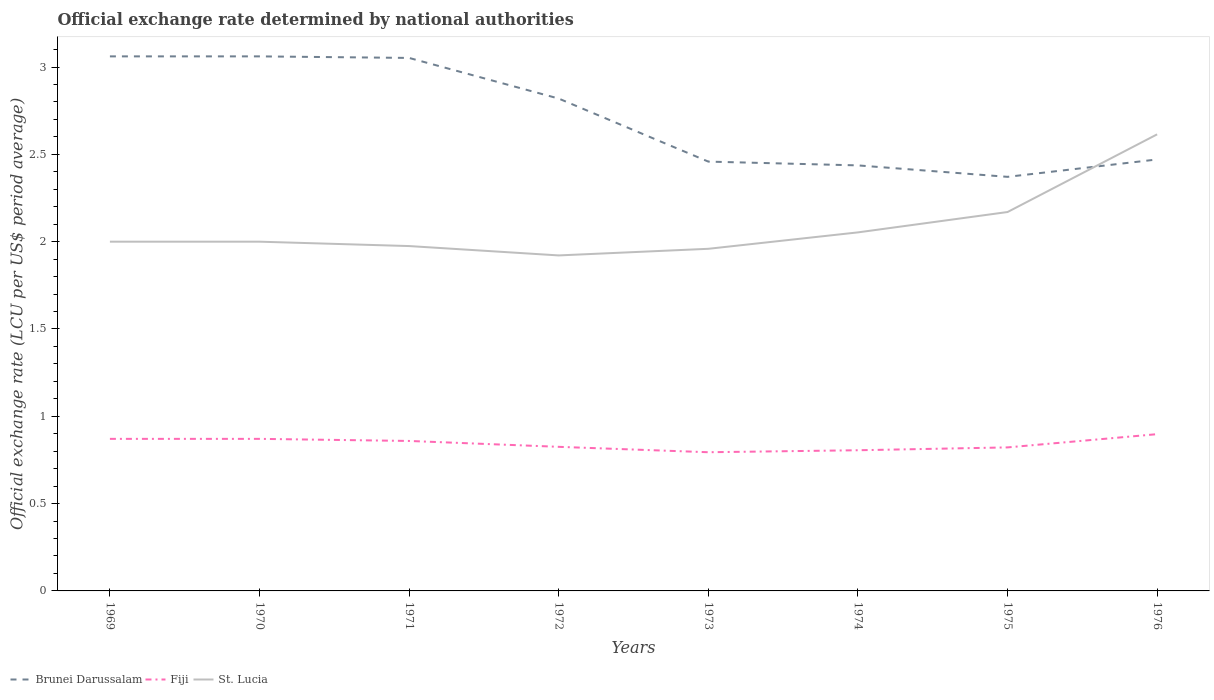How many different coloured lines are there?
Offer a terse response. 3. Is the number of lines equal to the number of legend labels?
Offer a terse response. Yes. Across all years, what is the maximum official exchange rate in St. Lucia?
Your response must be concise. 1.92. In which year was the official exchange rate in St. Lucia maximum?
Keep it short and to the point. 1972. What is the total official exchange rate in St. Lucia in the graph?
Ensure brevity in your answer.  -0.08. What is the difference between the highest and the second highest official exchange rate in St. Lucia?
Make the answer very short. 0.69. Is the official exchange rate in Brunei Darussalam strictly greater than the official exchange rate in St. Lucia over the years?
Make the answer very short. No. How are the legend labels stacked?
Keep it short and to the point. Horizontal. What is the title of the graph?
Keep it short and to the point. Official exchange rate determined by national authorities. Does "Slovenia" appear as one of the legend labels in the graph?
Your answer should be compact. No. What is the label or title of the Y-axis?
Give a very brief answer. Official exchange rate (LCU per US$ period average). What is the Official exchange rate (LCU per US$ period average) in Brunei Darussalam in 1969?
Your answer should be very brief. 3.06. What is the Official exchange rate (LCU per US$ period average) of Fiji in 1969?
Ensure brevity in your answer.  0.87. What is the Official exchange rate (LCU per US$ period average) of St. Lucia in 1969?
Offer a very short reply. 2. What is the Official exchange rate (LCU per US$ period average) of Brunei Darussalam in 1970?
Provide a succinct answer. 3.06. What is the Official exchange rate (LCU per US$ period average) of Fiji in 1970?
Ensure brevity in your answer.  0.87. What is the Official exchange rate (LCU per US$ period average) in St. Lucia in 1970?
Give a very brief answer. 2. What is the Official exchange rate (LCU per US$ period average) in Brunei Darussalam in 1971?
Your answer should be very brief. 3.05. What is the Official exchange rate (LCU per US$ period average) in Fiji in 1971?
Offer a terse response. 0.86. What is the Official exchange rate (LCU per US$ period average) of St. Lucia in 1971?
Offer a very short reply. 1.97. What is the Official exchange rate (LCU per US$ period average) in Brunei Darussalam in 1972?
Give a very brief answer. 2.82. What is the Official exchange rate (LCU per US$ period average) of Fiji in 1972?
Keep it short and to the point. 0.83. What is the Official exchange rate (LCU per US$ period average) in St. Lucia in 1972?
Provide a succinct answer. 1.92. What is the Official exchange rate (LCU per US$ period average) of Brunei Darussalam in 1973?
Your answer should be compact. 2.46. What is the Official exchange rate (LCU per US$ period average) of Fiji in 1973?
Give a very brief answer. 0.79. What is the Official exchange rate (LCU per US$ period average) of St. Lucia in 1973?
Make the answer very short. 1.96. What is the Official exchange rate (LCU per US$ period average) of Brunei Darussalam in 1974?
Give a very brief answer. 2.44. What is the Official exchange rate (LCU per US$ period average) in Fiji in 1974?
Ensure brevity in your answer.  0.81. What is the Official exchange rate (LCU per US$ period average) in St. Lucia in 1974?
Offer a very short reply. 2.05. What is the Official exchange rate (LCU per US$ period average) in Brunei Darussalam in 1975?
Keep it short and to the point. 2.37. What is the Official exchange rate (LCU per US$ period average) of Fiji in 1975?
Give a very brief answer. 0.82. What is the Official exchange rate (LCU per US$ period average) in St. Lucia in 1975?
Offer a very short reply. 2.17. What is the Official exchange rate (LCU per US$ period average) in Brunei Darussalam in 1976?
Ensure brevity in your answer.  2.47. What is the Official exchange rate (LCU per US$ period average) of Fiji in 1976?
Ensure brevity in your answer.  0.9. What is the Official exchange rate (LCU per US$ period average) in St. Lucia in 1976?
Ensure brevity in your answer.  2.61. Across all years, what is the maximum Official exchange rate (LCU per US$ period average) of Brunei Darussalam?
Give a very brief answer. 3.06. Across all years, what is the maximum Official exchange rate (LCU per US$ period average) of Fiji?
Provide a short and direct response. 0.9. Across all years, what is the maximum Official exchange rate (LCU per US$ period average) of St. Lucia?
Your answer should be very brief. 2.61. Across all years, what is the minimum Official exchange rate (LCU per US$ period average) of Brunei Darussalam?
Provide a short and direct response. 2.37. Across all years, what is the minimum Official exchange rate (LCU per US$ period average) in Fiji?
Your answer should be compact. 0.79. Across all years, what is the minimum Official exchange rate (LCU per US$ period average) in St. Lucia?
Offer a very short reply. 1.92. What is the total Official exchange rate (LCU per US$ period average) of Brunei Darussalam in the graph?
Make the answer very short. 21.73. What is the total Official exchange rate (LCU per US$ period average) in Fiji in the graph?
Ensure brevity in your answer.  6.75. What is the total Official exchange rate (LCU per US$ period average) of St. Lucia in the graph?
Make the answer very short. 16.69. What is the difference between the Official exchange rate (LCU per US$ period average) in Brunei Darussalam in 1969 and that in 1970?
Your answer should be very brief. 0. What is the difference between the Official exchange rate (LCU per US$ period average) in Brunei Darussalam in 1969 and that in 1971?
Provide a succinct answer. 0.01. What is the difference between the Official exchange rate (LCU per US$ period average) in Fiji in 1969 and that in 1971?
Your response must be concise. 0.01. What is the difference between the Official exchange rate (LCU per US$ period average) in St. Lucia in 1969 and that in 1971?
Ensure brevity in your answer.  0.03. What is the difference between the Official exchange rate (LCU per US$ period average) in Brunei Darussalam in 1969 and that in 1972?
Offer a very short reply. 0.24. What is the difference between the Official exchange rate (LCU per US$ period average) of Fiji in 1969 and that in 1972?
Your answer should be compact. 0.05. What is the difference between the Official exchange rate (LCU per US$ period average) of St. Lucia in 1969 and that in 1972?
Your answer should be compact. 0.08. What is the difference between the Official exchange rate (LCU per US$ period average) of Brunei Darussalam in 1969 and that in 1973?
Make the answer very short. 0.6. What is the difference between the Official exchange rate (LCU per US$ period average) in Fiji in 1969 and that in 1973?
Offer a very short reply. 0.08. What is the difference between the Official exchange rate (LCU per US$ period average) of St. Lucia in 1969 and that in 1973?
Give a very brief answer. 0.04. What is the difference between the Official exchange rate (LCU per US$ period average) of Brunei Darussalam in 1969 and that in 1974?
Your answer should be very brief. 0.62. What is the difference between the Official exchange rate (LCU per US$ period average) in Fiji in 1969 and that in 1974?
Keep it short and to the point. 0.07. What is the difference between the Official exchange rate (LCU per US$ period average) of St. Lucia in 1969 and that in 1974?
Your response must be concise. -0.05. What is the difference between the Official exchange rate (LCU per US$ period average) in Brunei Darussalam in 1969 and that in 1975?
Offer a terse response. 0.69. What is the difference between the Official exchange rate (LCU per US$ period average) of Fiji in 1969 and that in 1975?
Your answer should be compact. 0.05. What is the difference between the Official exchange rate (LCU per US$ period average) in St. Lucia in 1969 and that in 1975?
Give a very brief answer. -0.17. What is the difference between the Official exchange rate (LCU per US$ period average) of Brunei Darussalam in 1969 and that in 1976?
Offer a very short reply. 0.59. What is the difference between the Official exchange rate (LCU per US$ period average) of Fiji in 1969 and that in 1976?
Make the answer very short. -0.03. What is the difference between the Official exchange rate (LCU per US$ period average) in St. Lucia in 1969 and that in 1976?
Make the answer very short. -0.61. What is the difference between the Official exchange rate (LCU per US$ period average) in Brunei Darussalam in 1970 and that in 1971?
Provide a succinct answer. 0.01. What is the difference between the Official exchange rate (LCU per US$ period average) in Fiji in 1970 and that in 1971?
Give a very brief answer. 0.01. What is the difference between the Official exchange rate (LCU per US$ period average) of St. Lucia in 1970 and that in 1971?
Your response must be concise. 0.03. What is the difference between the Official exchange rate (LCU per US$ period average) of Brunei Darussalam in 1970 and that in 1972?
Provide a short and direct response. 0.24. What is the difference between the Official exchange rate (LCU per US$ period average) in Fiji in 1970 and that in 1972?
Make the answer very short. 0.05. What is the difference between the Official exchange rate (LCU per US$ period average) in St. Lucia in 1970 and that in 1972?
Provide a succinct answer. 0.08. What is the difference between the Official exchange rate (LCU per US$ period average) of Brunei Darussalam in 1970 and that in 1973?
Your response must be concise. 0.6. What is the difference between the Official exchange rate (LCU per US$ period average) in Fiji in 1970 and that in 1973?
Ensure brevity in your answer.  0.08. What is the difference between the Official exchange rate (LCU per US$ period average) in St. Lucia in 1970 and that in 1973?
Ensure brevity in your answer.  0.04. What is the difference between the Official exchange rate (LCU per US$ period average) of Brunei Darussalam in 1970 and that in 1974?
Keep it short and to the point. 0.62. What is the difference between the Official exchange rate (LCU per US$ period average) in Fiji in 1970 and that in 1974?
Offer a terse response. 0.07. What is the difference between the Official exchange rate (LCU per US$ period average) of St. Lucia in 1970 and that in 1974?
Make the answer very short. -0.05. What is the difference between the Official exchange rate (LCU per US$ period average) of Brunei Darussalam in 1970 and that in 1975?
Give a very brief answer. 0.69. What is the difference between the Official exchange rate (LCU per US$ period average) in Fiji in 1970 and that in 1975?
Your response must be concise. 0.05. What is the difference between the Official exchange rate (LCU per US$ period average) of St. Lucia in 1970 and that in 1975?
Your answer should be very brief. -0.17. What is the difference between the Official exchange rate (LCU per US$ period average) in Brunei Darussalam in 1970 and that in 1976?
Keep it short and to the point. 0.59. What is the difference between the Official exchange rate (LCU per US$ period average) of Fiji in 1970 and that in 1976?
Keep it short and to the point. -0.03. What is the difference between the Official exchange rate (LCU per US$ period average) of St. Lucia in 1970 and that in 1976?
Offer a terse response. -0.61. What is the difference between the Official exchange rate (LCU per US$ period average) in Brunei Darussalam in 1971 and that in 1972?
Your answer should be very brief. 0.23. What is the difference between the Official exchange rate (LCU per US$ period average) in Fiji in 1971 and that in 1972?
Offer a terse response. 0.03. What is the difference between the Official exchange rate (LCU per US$ period average) in St. Lucia in 1971 and that in 1972?
Keep it short and to the point. 0.05. What is the difference between the Official exchange rate (LCU per US$ period average) in Brunei Darussalam in 1971 and that in 1973?
Offer a terse response. 0.59. What is the difference between the Official exchange rate (LCU per US$ period average) in Fiji in 1971 and that in 1973?
Offer a terse response. 0.06. What is the difference between the Official exchange rate (LCU per US$ period average) of St. Lucia in 1971 and that in 1973?
Your answer should be compact. 0.02. What is the difference between the Official exchange rate (LCU per US$ period average) in Brunei Darussalam in 1971 and that in 1974?
Make the answer very short. 0.62. What is the difference between the Official exchange rate (LCU per US$ period average) of Fiji in 1971 and that in 1974?
Give a very brief answer. 0.05. What is the difference between the Official exchange rate (LCU per US$ period average) of St. Lucia in 1971 and that in 1974?
Your response must be concise. -0.08. What is the difference between the Official exchange rate (LCU per US$ period average) in Brunei Darussalam in 1971 and that in 1975?
Make the answer very short. 0.68. What is the difference between the Official exchange rate (LCU per US$ period average) of Fiji in 1971 and that in 1975?
Your answer should be compact. 0.04. What is the difference between the Official exchange rate (LCU per US$ period average) in St. Lucia in 1971 and that in 1975?
Ensure brevity in your answer.  -0.19. What is the difference between the Official exchange rate (LCU per US$ period average) in Brunei Darussalam in 1971 and that in 1976?
Provide a succinct answer. 0.58. What is the difference between the Official exchange rate (LCU per US$ period average) in Fiji in 1971 and that in 1976?
Your answer should be compact. -0.04. What is the difference between the Official exchange rate (LCU per US$ period average) in St. Lucia in 1971 and that in 1976?
Ensure brevity in your answer.  -0.64. What is the difference between the Official exchange rate (LCU per US$ period average) in Brunei Darussalam in 1972 and that in 1973?
Provide a succinct answer. 0.36. What is the difference between the Official exchange rate (LCU per US$ period average) of Fiji in 1972 and that in 1973?
Provide a succinct answer. 0.03. What is the difference between the Official exchange rate (LCU per US$ period average) in St. Lucia in 1972 and that in 1973?
Provide a succinct answer. -0.04. What is the difference between the Official exchange rate (LCU per US$ period average) in Brunei Darussalam in 1972 and that in 1974?
Provide a short and direct response. 0.38. What is the difference between the Official exchange rate (LCU per US$ period average) of Fiji in 1972 and that in 1974?
Offer a terse response. 0.02. What is the difference between the Official exchange rate (LCU per US$ period average) in St. Lucia in 1972 and that in 1974?
Give a very brief answer. -0.13. What is the difference between the Official exchange rate (LCU per US$ period average) in Brunei Darussalam in 1972 and that in 1975?
Offer a very short reply. 0.45. What is the difference between the Official exchange rate (LCU per US$ period average) of Fiji in 1972 and that in 1975?
Make the answer very short. 0. What is the difference between the Official exchange rate (LCU per US$ period average) in St. Lucia in 1972 and that in 1975?
Offer a terse response. -0.25. What is the difference between the Official exchange rate (LCU per US$ period average) in Brunei Darussalam in 1972 and that in 1976?
Your answer should be very brief. 0.35. What is the difference between the Official exchange rate (LCU per US$ period average) of Fiji in 1972 and that in 1976?
Your answer should be compact. -0.07. What is the difference between the Official exchange rate (LCU per US$ period average) of St. Lucia in 1972 and that in 1976?
Your response must be concise. -0.69. What is the difference between the Official exchange rate (LCU per US$ period average) in Brunei Darussalam in 1973 and that in 1974?
Keep it short and to the point. 0.02. What is the difference between the Official exchange rate (LCU per US$ period average) in Fiji in 1973 and that in 1974?
Keep it short and to the point. -0.01. What is the difference between the Official exchange rate (LCU per US$ period average) in St. Lucia in 1973 and that in 1974?
Ensure brevity in your answer.  -0.09. What is the difference between the Official exchange rate (LCU per US$ period average) of Brunei Darussalam in 1973 and that in 1975?
Your answer should be compact. 0.09. What is the difference between the Official exchange rate (LCU per US$ period average) of Fiji in 1973 and that in 1975?
Ensure brevity in your answer.  -0.03. What is the difference between the Official exchange rate (LCU per US$ period average) in St. Lucia in 1973 and that in 1975?
Your answer should be very brief. -0.21. What is the difference between the Official exchange rate (LCU per US$ period average) in Brunei Darussalam in 1973 and that in 1976?
Give a very brief answer. -0.01. What is the difference between the Official exchange rate (LCU per US$ period average) of Fiji in 1973 and that in 1976?
Your answer should be compact. -0.1. What is the difference between the Official exchange rate (LCU per US$ period average) of St. Lucia in 1973 and that in 1976?
Ensure brevity in your answer.  -0.66. What is the difference between the Official exchange rate (LCU per US$ period average) of Brunei Darussalam in 1974 and that in 1975?
Give a very brief answer. 0.07. What is the difference between the Official exchange rate (LCU per US$ period average) of Fiji in 1974 and that in 1975?
Provide a short and direct response. -0.02. What is the difference between the Official exchange rate (LCU per US$ period average) of St. Lucia in 1974 and that in 1975?
Your answer should be compact. -0.12. What is the difference between the Official exchange rate (LCU per US$ period average) in Brunei Darussalam in 1974 and that in 1976?
Your answer should be very brief. -0.03. What is the difference between the Official exchange rate (LCU per US$ period average) of Fiji in 1974 and that in 1976?
Your response must be concise. -0.09. What is the difference between the Official exchange rate (LCU per US$ period average) of St. Lucia in 1974 and that in 1976?
Provide a short and direct response. -0.56. What is the difference between the Official exchange rate (LCU per US$ period average) of Brunei Darussalam in 1975 and that in 1976?
Your answer should be very brief. -0.1. What is the difference between the Official exchange rate (LCU per US$ period average) of Fiji in 1975 and that in 1976?
Offer a very short reply. -0.08. What is the difference between the Official exchange rate (LCU per US$ period average) of St. Lucia in 1975 and that in 1976?
Give a very brief answer. -0.44. What is the difference between the Official exchange rate (LCU per US$ period average) of Brunei Darussalam in 1969 and the Official exchange rate (LCU per US$ period average) of Fiji in 1970?
Your response must be concise. 2.19. What is the difference between the Official exchange rate (LCU per US$ period average) of Brunei Darussalam in 1969 and the Official exchange rate (LCU per US$ period average) of St. Lucia in 1970?
Ensure brevity in your answer.  1.06. What is the difference between the Official exchange rate (LCU per US$ period average) in Fiji in 1969 and the Official exchange rate (LCU per US$ period average) in St. Lucia in 1970?
Your answer should be very brief. -1.13. What is the difference between the Official exchange rate (LCU per US$ period average) of Brunei Darussalam in 1969 and the Official exchange rate (LCU per US$ period average) of Fiji in 1971?
Your answer should be compact. 2.2. What is the difference between the Official exchange rate (LCU per US$ period average) in Brunei Darussalam in 1969 and the Official exchange rate (LCU per US$ period average) in St. Lucia in 1971?
Your response must be concise. 1.09. What is the difference between the Official exchange rate (LCU per US$ period average) of Fiji in 1969 and the Official exchange rate (LCU per US$ period average) of St. Lucia in 1971?
Your answer should be very brief. -1.1. What is the difference between the Official exchange rate (LCU per US$ period average) of Brunei Darussalam in 1969 and the Official exchange rate (LCU per US$ period average) of Fiji in 1972?
Provide a succinct answer. 2.24. What is the difference between the Official exchange rate (LCU per US$ period average) in Brunei Darussalam in 1969 and the Official exchange rate (LCU per US$ period average) in St. Lucia in 1972?
Offer a terse response. 1.14. What is the difference between the Official exchange rate (LCU per US$ period average) of Fiji in 1969 and the Official exchange rate (LCU per US$ period average) of St. Lucia in 1972?
Your response must be concise. -1.05. What is the difference between the Official exchange rate (LCU per US$ period average) in Brunei Darussalam in 1969 and the Official exchange rate (LCU per US$ period average) in Fiji in 1973?
Provide a succinct answer. 2.27. What is the difference between the Official exchange rate (LCU per US$ period average) of Brunei Darussalam in 1969 and the Official exchange rate (LCU per US$ period average) of St. Lucia in 1973?
Offer a terse response. 1.1. What is the difference between the Official exchange rate (LCU per US$ period average) of Fiji in 1969 and the Official exchange rate (LCU per US$ period average) of St. Lucia in 1973?
Keep it short and to the point. -1.09. What is the difference between the Official exchange rate (LCU per US$ period average) of Brunei Darussalam in 1969 and the Official exchange rate (LCU per US$ period average) of Fiji in 1974?
Ensure brevity in your answer.  2.26. What is the difference between the Official exchange rate (LCU per US$ period average) in Fiji in 1969 and the Official exchange rate (LCU per US$ period average) in St. Lucia in 1974?
Provide a short and direct response. -1.18. What is the difference between the Official exchange rate (LCU per US$ period average) of Brunei Darussalam in 1969 and the Official exchange rate (LCU per US$ period average) of Fiji in 1975?
Give a very brief answer. 2.24. What is the difference between the Official exchange rate (LCU per US$ period average) of Brunei Darussalam in 1969 and the Official exchange rate (LCU per US$ period average) of St. Lucia in 1975?
Keep it short and to the point. 0.89. What is the difference between the Official exchange rate (LCU per US$ period average) of Fiji in 1969 and the Official exchange rate (LCU per US$ period average) of St. Lucia in 1975?
Your answer should be compact. -1.3. What is the difference between the Official exchange rate (LCU per US$ period average) of Brunei Darussalam in 1969 and the Official exchange rate (LCU per US$ period average) of Fiji in 1976?
Provide a short and direct response. 2.16. What is the difference between the Official exchange rate (LCU per US$ period average) in Brunei Darussalam in 1969 and the Official exchange rate (LCU per US$ period average) in St. Lucia in 1976?
Offer a very short reply. 0.45. What is the difference between the Official exchange rate (LCU per US$ period average) of Fiji in 1969 and the Official exchange rate (LCU per US$ period average) of St. Lucia in 1976?
Your answer should be very brief. -1.74. What is the difference between the Official exchange rate (LCU per US$ period average) of Brunei Darussalam in 1970 and the Official exchange rate (LCU per US$ period average) of Fiji in 1971?
Make the answer very short. 2.2. What is the difference between the Official exchange rate (LCU per US$ period average) in Brunei Darussalam in 1970 and the Official exchange rate (LCU per US$ period average) in St. Lucia in 1971?
Your answer should be very brief. 1.09. What is the difference between the Official exchange rate (LCU per US$ period average) of Fiji in 1970 and the Official exchange rate (LCU per US$ period average) of St. Lucia in 1971?
Offer a very short reply. -1.1. What is the difference between the Official exchange rate (LCU per US$ period average) in Brunei Darussalam in 1970 and the Official exchange rate (LCU per US$ period average) in Fiji in 1972?
Make the answer very short. 2.24. What is the difference between the Official exchange rate (LCU per US$ period average) in Brunei Darussalam in 1970 and the Official exchange rate (LCU per US$ period average) in St. Lucia in 1972?
Make the answer very short. 1.14. What is the difference between the Official exchange rate (LCU per US$ period average) of Fiji in 1970 and the Official exchange rate (LCU per US$ period average) of St. Lucia in 1972?
Your answer should be very brief. -1.05. What is the difference between the Official exchange rate (LCU per US$ period average) of Brunei Darussalam in 1970 and the Official exchange rate (LCU per US$ period average) of Fiji in 1973?
Provide a short and direct response. 2.27. What is the difference between the Official exchange rate (LCU per US$ period average) in Brunei Darussalam in 1970 and the Official exchange rate (LCU per US$ period average) in St. Lucia in 1973?
Ensure brevity in your answer.  1.1. What is the difference between the Official exchange rate (LCU per US$ period average) in Fiji in 1970 and the Official exchange rate (LCU per US$ period average) in St. Lucia in 1973?
Provide a succinct answer. -1.09. What is the difference between the Official exchange rate (LCU per US$ period average) in Brunei Darussalam in 1970 and the Official exchange rate (LCU per US$ period average) in Fiji in 1974?
Your answer should be compact. 2.26. What is the difference between the Official exchange rate (LCU per US$ period average) of Fiji in 1970 and the Official exchange rate (LCU per US$ period average) of St. Lucia in 1974?
Offer a very short reply. -1.18. What is the difference between the Official exchange rate (LCU per US$ period average) in Brunei Darussalam in 1970 and the Official exchange rate (LCU per US$ period average) in Fiji in 1975?
Your answer should be compact. 2.24. What is the difference between the Official exchange rate (LCU per US$ period average) in Brunei Darussalam in 1970 and the Official exchange rate (LCU per US$ period average) in St. Lucia in 1975?
Offer a very short reply. 0.89. What is the difference between the Official exchange rate (LCU per US$ period average) of Fiji in 1970 and the Official exchange rate (LCU per US$ period average) of St. Lucia in 1975?
Give a very brief answer. -1.3. What is the difference between the Official exchange rate (LCU per US$ period average) in Brunei Darussalam in 1970 and the Official exchange rate (LCU per US$ period average) in Fiji in 1976?
Keep it short and to the point. 2.16. What is the difference between the Official exchange rate (LCU per US$ period average) in Brunei Darussalam in 1970 and the Official exchange rate (LCU per US$ period average) in St. Lucia in 1976?
Offer a terse response. 0.45. What is the difference between the Official exchange rate (LCU per US$ period average) in Fiji in 1970 and the Official exchange rate (LCU per US$ period average) in St. Lucia in 1976?
Offer a terse response. -1.74. What is the difference between the Official exchange rate (LCU per US$ period average) of Brunei Darussalam in 1971 and the Official exchange rate (LCU per US$ period average) of Fiji in 1972?
Offer a very short reply. 2.23. What is the difference between the Official exchange rate (LCU per US$ period average) in Brunei Darussalam in 1971 and the Official exchange rate (LCU per US$ period average) in St. Lucia in 1972?
Offer a terse response. 1.13. What is the difference between the Official exchange rate (LCU per US$ period average) of Fiji in 1971 and the Official exchange rate (LCU per US$ period average) of St. Lucia in 1972?
Offer a very short reply. -1.06. What is the difference between the Official exchange rate (LCU per US$ period average) in Brunei Darussalam in 1971 and the Official exchange rate (LCU per US$ period average) in Fiji in 1973?
Provide a succinct answer. 2.26. What is the difference between the Official exchange rate (LCU per US$ period average) in Brunei Darussalam in 1971 and the Official exchange rate (LCU per US$ period average) in St. Lucia in 1973?
Give a very brief answer. 1.09. What is the difference between the Official exchange rate (LCU per US$ period average) in Fiji in 1971 and the Official exchange rate (LCU per US$ period average) in St. Lucia in 1973?
Ensure brevity in your answer.  -1.1. What is the difference between the Official exchange rate (LCU per US$ period average) in Brunei Darussalam in 1971 and the Official exchange rate (LCU per US$ period average) in Fiji in 1974?
Your answer should be compact. 2.25. What is the difference between the Official exchange rate (LCU per US$ period average) in Brunei Darussalam in 1971 and the Official exchange rate (LCU per US$ period average) in St. Lucia in 1974?
Keep it short and to the point. 1. What is the difference between the Official exchange rate (LCU per US$ period average) in Fiji in 1971 and the Official exchange rate (LCU per US$ period average) in St. Lucia in 1974?
Provide a succinct answer. -1.19. What is the difference between the Official exchange rate (LCU per US$ period average) of Brunei Darussalam in 1971 and the Official exchange rate (LCU per US$ period average) of Fiji in 1975?
Your answer should be compact. 2.23. What is the difference between the Official exchange rate (LCU per US$ period average) in Brunei Darussalam in 1971 and the Official exchange rate (LCU per US$ period average) in St. Lucia in 1975?
Offer a terse response. 0.88. What is the difference between the Official exchange rate (LCU per US$ period average) of Fiji in 1971 and the Official exchange rate (LCU per US$ period average) of St. Lucia in 1975?
Your answer should be very brief. -1.31. What is the difference between the Official exchange rate (LCU per US$ period average) in Brunei Darussalam in 1971 and the Official exchange rate (LCU per US$ period average) in Fiji in 1976?
Offer a terse response. 2.15. What is the difference between the Official exchange rate (LCU per US$ period average) in Brunei Darussalam in 1971 and the Official exchange rate (LCU per US$ period average) in St. Lucia in 1976?
Keep it short and to the point. 0.44. What is the difference between the Official exchange rate (LCU per US$ period average) in Fiji in 1971 and the Official exchange rate (LCU per US$ period average) in St. Lucia in 1976?
Your response must be concise. -1.76. What is the difference between the Official exchange rate (LCU per US$ period average) in Brunei Darussalam in 1972 and the Official exchange rate (LCU per US$ period average) in Fiji in 1973?
Keep it short and to the point. 2.03. What is the difference between the Official exchange rate (LCU per US$ period average) in Brunei Darussalam in 1972 and the Official exchange rate (LCU per US$ period average) in St. Lucia in 1973?
Offer a very short reply. 0.86. What is the difference between the Official exchange rate (LCU per US$ period average) of Fiji in 1972 and the Official exchange rate (LCU per US$ period average) of St. Lucia in 1973?
Make the answer very short. -1.13. What is the difference between the Official exchange rate (LCU per US$ period average) of Brunei Darussalam in 1972 and the Official exchange rate (LCU per US$ period average) of Fiji in 1974?
Make the answer very short. 2.01. What is the difference between the Official exchange rate (LCU per US$ period average) in Brunei Darussalam in 1972 and the Official exchange rate (LCU per US$ period average) in St. Lucia in 1974?
Your answer should be compact. 0.77. What is the difference between the Official exchange rate (LCU per US$ period average) of Fiji in 1972 and the Official exchange rate (LCU per US$ period average) of St. Lucia in 1974?
Keep it short and to the point. -1.23. What is the difference between the Official exchange rate (LCU per US$ period average) of Brunei Darussalam in 1972 and the Official exchange rate (LCU per US$ period average) of Fiji in 1975?
Give a very brief answer. 2. What is the difference between the Official exchange rate (LCU per US$ period average) of Brunei Darussalam in 1972 and the Official exchange rate (LCU per US$ period average) of St. Lucia in 1975?
Provide a short and direct response. 0.65. What is the difference between the Official exchange rate (LCU per US$ period average) of Fiji in 1972 and the Official exchange rate (LCU per US$ period average) of St. Lucia in 1975?
Ensure brevity in your answer.  -1.34. What is the difference between the Official exchange rate (LCU per US$ period average) of Brunei Darussalam in 1972 and the Official exchange rate (LCU per US$ period average) of Fiji in 1976?
Your response must be concise. 1.92. What is the difference between the Official exchange rate (LCU per US$ period average) in Brunei Darussalam in 1972 and the Official exchange rate (LCU per US$ period average) in St. Lucia in 1976?
Provide a succinct answer. 0.2. What is the difference between the Official exchange rate (LCU per US$ period average) of Fiji in 1972 and the Official exchange rate (LCU per US$ period average) of St. Lucia in 1976?
Make the answer very short. -1.79. What is the difference between the Official exchange rate (LCU per US$ period average) of Brunei Darussalam in 1973 and the Official exchange rate (LCU per US$ period average) of Fiji in 1974?
Make the answer very short. 1.65. What is the difference between the Official exchange rate (LCU per US$ period average) of Brunei Darussalam in 1973 and the Official exchange rate (LCU per US$ period average) of St. Lucia in 1974?
Your answer should be compact. 0.41. What is the difference between the Official exchange rate (LCU per US$ period average) of Fiji in 1973 and the Official exchange rate (LCU per US$ period average) of St. Lucia in 1974?
Your answer should be very brief. -1.26. What is the difference between the Official exchange rate (LCU per US$ period average) of Brunei Darussalam in 1973 and the Official exchange rate (LCU per US$ period average) of Fiji in 1975?
Offer a terse response. 1.64. What is the difference between the Official exchange rate (LCU per US$ period average) of Brunei Darussalam in 1973 and the Official exchange rate (LCU per US$ period average) of St. Lucia in 1975?
Your response must be concise. 0.29. What is the difference between the Official exchange rate (LCU per US$ period average) in Fiji in 1973 and the Official exchange rate (LCU per US$ period average) in St. Lucia in 1975?
Ensure brevity in your answer.  -1.38. What is the difference between the Official exchange rate (LCU per US$ period average) of Brunei Darussalam in 1973 and the Official exchange rate (LCU per US$ period average) of Fiji in 1976?
Offer a terse response. 1.56. What is the difference between the Official exchange rate (LCU per US$ period average) of Brunei Darussalam in 1973 and the Official exchange rate (LCU per US$ period average) of St. Lucia in 1976?
Give a very brief answer. -0.16. What is the difference between the Official exchange rate (LCU per US$ period average) in Fiji in 1973 and the Official exchange rate (LCU per US$ period average) in St. Lucia in 1976?
Your answer should be very brief. -1.82. What is the difference between the Official exchange rate (LCU per US$ period average) of Brunei Darussalam in 1974 and the Official exchange rate (LCU per US$ period average) of Fiji in 1975?
Your response must be concise. 1.61. What is the difference between the Official exchange rate (LCU per US$ period average) in Brunei Darussalam in 1974 and the Official exchange rate (LCU per US$ period average) in St. Lucia in 1975?
Give a very brief answer. 0.27. What is the difference between the Official exchange rate (LCU per US$ period average) of Fiji in 1974 and the Official exchange rate (LCU per US$ period average) of St. Lucia in 1975?
Provide a succinct answer. -1.36. What is the difference between the Official exchange rate (LCU per US$ period average) in Brunei Darussalam in 1974 and the Official exchange rate (LCU per US$ period average) in Fiji in 1976?
Offer a very short reply. 1.54. What is the difference between the Official exchange rate (LCU per US$ period average) of Brunei Darussalam in 1974 and the Official exchange rate (LCU per US$ period average) of St. Lucia in 1976?
Make the answer very short. -0.18. What is the difference between the Official exchange rate (LCU per US$ period average) in Fiji in 1974 and the Official exchange rate (LCU per US$ period average) in St. Lucia in 1976?
Your answer should be compact. -1.81. What is the difference between the Official exchange rate (LCU per US$ period average) of Brunei Darussalam in 1975 and the Official exchange rate (LCU per US$ period average) of Fiji in 1976?
Give a very brief answer. 1.47. What is the difference between the Official exchange rate (LCU per US$ period average) in Brunei Darussalam in 1975 and the Official exchange rate (LCU per US$ period average) in St. Lucia in 1976?
Provide a short and direct response. -0.24. What is the difference between the Official exchange rate (LCU per US$ period average) of Fiji in 1975 and the Official exchange rate (LCU per US$ period average) of St. Lucia in 1976?
Offer a very short reply. -1.79. What is the average Official exchange rate (LCU per US$ period average) in Brunei Darussalam per year?
Give a very brief answer. 2.72. What is the average Official exchange rate (LCU per US$ period average) in Fiji per year?
Make the answer very short. 0.84. What is the average Official exchange rate (LCU per US$ period average) in St. Lucia per year?
Your response must be concise. 2.09. In the year 1969, what is the difference between the Official exchange rate (LCU per US$ period average) of Brunei Darussalam and Official exchange rate (LCU per US$ period average) of Fiji?
Give a very brief answer. 2.19. In the year 1969, what is the difference between the Official exchange rate (LCU per US$ period average) of Brunei Darussalam and Official exchange rate (LCU per US$ period average) of St. Lucia?
Provide a short and direct response. 1.06. In the year 1969, what is the difference between the Official exchange rate (LCU per US$ period average) of Fiji and Official exchange rate (LCU per US$ period average) of St. Lucia?
Make the answer very short. -1.13. In the year 1970, what is the difference between the Official exchange rate (LCU per US$ period average) of Brunei Darussalam and Official exchange rate (LCU per US$ period average) of Fiji?
Provide a succinct answer. 2.19. In the year 1970, what is the difference between the Official exchange rate (LCU per US$ period average) of Brunei Darussalam and Official exchange rate (LCU per US$ period average) of St. Lucia?
Make the answer very short. 1.06. In the year 1970, what is the difference between the Official exchange rate (LCU per US$ period average) of Fiji and Official exchange rate (LCU per US$ period average) of St. Lucia?
Offer a very short reply. -1.13. In the year 1971, what is the difference between the Official exchange rate (LCU per US$ period average) in Brunei Darussalam and Official exchange rate (LCU per US$ period average) in Fiji?
Provide a short and direct response. 2.19. In the year 1971, what is the difference between the Official exchange rate (LCU per US$ period average) in Brunei Darussalam and Official exchange rate (LCU per US$ period average) in St. Lucia?
Your answer should be very brief. 1.08. In the year 1971, what is the difference between the Official exchange rate (LCU per US$ period average) of Fiji and Official exchange rate (LCU per US$ period average) of St. Lucia?
Your response must be concise. -1.12. In the year 1972, what is the difference between the Official exchange rate (LCU per US$ period average) in Brunei Darussalam and Official exchange rate (LCU per US$ period average) in Fiji?
Your answer should be compact. 1.99. In the year 1972, what is the difference between the Official exchange rate (LCU per US$ period average) in Brunei Darussalam and Official exchange rate (LCU per US$ period average) in St. Lucia?
Your answer should be compact. 0.9. In the year 1972, what is the difference between the Official exchange rate (LCU per US$ period average) in Fiji and Official exchange rate (LCU per US$ period average) in St. Lucia?
Your answer should be very brief. -1.1. In the year 1973, what is the difference between the Official exchange rate (LCU per US$ period average) of Brunei Darussalam and Official exchange rate (LCU per US$ period average) of Fiji?
Keep it short and to the point. 1.66. In the year 1973, what is the difference between the Official exchange rate (LCU per US$ period average) of Brunei Darussalam and Official exchange rate (LCU per US$ period average) of St. Lucia?
Ensure brevity in your answer.  0.5. In the year 1973, what is the difference between the Official exchange rate (LCU per US$ period average) of Fiji and Official exchange rate (LCU per US$ period average) of St. Lucia?
Ensure brevity in your answer.  -1.17. In the year 1974, what is the difference between the Official exchange rate (LCU per US$ period average) of Brunei Darussalam and Official exchange rate (LCU per US$ period average) of Fiji?
Offer a very short reply. 1.63. In the year 1974, what is the difference between the Official exchange rate (LCU per US$ period average) in Brunei Darussalam and Official exchange rate (LCU per US$ period average) in St. Lucia?
Your answer should be compact. 0.38. In the year 1974, what is the difference between the Official exchange rate (LCU per US$ period average) in Fiji and Official exchange rate (LCU per US$ period average) in St. Lucia?
Ensure brevity in your answer.  -1.25. In the year 1975, what is the difference between the Official exchange rate (LCU per US$ period average) of Brunei Darussalam and Official exchange rate (LCU per US$ period average) of Fiji?
Provide a short and direct response. 1.55. In the year 1975, what is the difference between the Official exchange rate (LCU per US$ period average) of Brunei Darussalam and Official exchange rate (LCU per US$ period average) of St. Lucia?
Provide a short and direct response. 0.2. In the year 1975, what is the difference between the Official exchange rate (LCU per US$ period average) of Fiji and Official exchange rate (LCU per US$ period average) of St. Lucia?
Your answer should be compact. -1.35. In the year 1976, what is the difference between the Official exchange rate (LCU per US$ period average) of Brunei Darussalam and Official exchange rate (LCU per US$ period average) of Fiji?
Offer a very short reply. 1.57. In the year 1976, what is the difference between the Official exchange rate (LCU per US$ period average) in Brunei Darussalam and Official exchange rate (LCU per US$ period average) in St. Lucia?
Make the answer very short. -0.14. In the year 1976, what is the difference between the Official exchange rate (LCU per US$ period average) in Fiji and Official exchange rate (LCU per US$ period average) in St. Lucia?
Offer a very short reply. -1.72. What is the ratio of the Official exchange rate (LCU per US$ period average) in Brunei Darussalam in 1969 to that in 1971?
Make the answer very short. 1. What is the ratio of the Official exchange rate (LCU per US$ period average) in Fiji in 1969 to that in 1971?
Make the answer very short. 1.01. What is the ratio of the Official exchange rate (LCU per US$ period average) in St. Lucia in 1969 to that in 1971?
Ensure brevity in your answer.  1.01. What is the ratio of the Official exchange rate (LCU per US$ period average) of Brunei Darussalam in 1969 to that in 1972?
Your answer should be very brief. 1.09. What is the ratio of the Official exchange rate (LCU per US$ period average) in Fiji in 1969 to that in 1972?
Offer a very short reply. 1.06. What is the ratio of the Official exchange rate (LCU per US$ period average) in St. Lucia in 1969 to that in 1972?
Give a very brief answer. 1.04. What is the ratio of the Official exchange rate (LCU per US$ period average) of Brunei Darussalam in 1969 to that in 1973?
Provide a short and direct response. 1.25. What is the ratio of the Official exchange rate (LCU per US$ period average) in Fiji in 1969 to that in 1973?
Ensure brevity in your answer.  1.1. What is the ratio of the Official exchange rate (LCU per US$ period average) of St. Lucia in 1969 to that in 1973?
Make the answer very short. 1.02. What is the ratio of the Official exchange rate (LCU per US$ period average) of Brunei Darussalam in 1969 to that in 1974?
Keep it short and to the point. 1.26. What is the ratio of the Official exchange rate (LCU per US$ period average) in Fiji in 1969 to that in 1974?
Offer a very short reply. 1.08. What is the ratio of the Official exchange rate (LCU per US$ period average) in St. Lucia in 1969 to that in 1974?
Provide a succinct answer. 0.97. What is the ratio of the Official exchange rate (LCU per US$ period average) in Brunei Darussalam in 1969 to that in 1975?
Your response must be concise. 1.29. What is the ratio of the Official exchange rate (LCU per US$ period average) of Fiji in 1969 to that in 1975?
Make the answer very short. 1.06. What is the ratio of the Official exchange rate (LCU per US$ period average) in St. Lucia in 1969 to that in 1975?
Ensure brevity in your answer.  0.92. What is the ratio of the Official exchange rate (LCU per US$ period average) of Brunei Darussalam in 1969 to that in 1976?
Ensure brevity in your answer.  1.24. What is the ratio of the Official exchange rate (LCU per US$ period average) in Fiji in 1969 to that in 1976?
Ensure brevity in your answer.  0.97. What is the ratio of the Official exchange rate (LCU per US$ period average) of St. Lucia in 1969 to that in 1976?
Keep it short and to the point. 0.76. What is the ratio of the Official exchange rate (LCU per US$ period average) in Brunei Darussalam in 1970 to that in 1971?
Your answer should be very brief. 1. What is the ratio of the Official exchange rate (LCU per US$ period average) in St. Lucia in 1970 to that in 1971?
Make the answer very short. 1.01. What is the ratio of the Official exchange rate (LCU per US$ period average) of Brunei Darussalam in 1970 to that in 1972?
Give a very brief answer. 1.09. What is the ratio of the Official exchange rate (LCU per US$ period average) of Fiji in 1970 to that in 1972?
Your answer should be compact. 1.06. What is the ratio of the Official exchange rate (LCU per US$ period average) in St. Lucia in 1970 to that in 1972?
Provide a short and direct response. 1.04. What is the ratio of the Official exchange rate (LCU per US$ period average) in Brunei Darussalam in 1970 to that in 1973?
Give a very brief answer. 1.25. What is the ratio of the Official exchange rate (LCU per US$ period average) in Fiji in 1970 to that in 1973?
Your response must be concise. 1.1. What is the ratio of the Official exchange rate (LCU per US$ period average) in St. Lucia in 1970 to that in 1973?
Make the answer very short. 1.02. What is the ratio of the Official exchange rate (LCU per US$ period average) of Brunei Darussalam in 1970 to that in 1974?
Provide a succinct answer. 1.26. What is the ratio of the Official exchange rate (LCU per US$ period average) of Fiji in 1970 to that in 1974?
Your answer should be compact. 1.08. What is the ratio of the Official exchange rate (LCU per US$ period average) of St. Lucia in 1970 to that in 1974?
Ensure brevity in your answer.  0.97. What is the ratio of the Official exchange rate (LCU per US$ period average) of Brunei Darussalam in 1970 to that in 1975?
Your answer should be compact. 1.29. What is the ratio of the Official exchange rate (LCU per US$ period average) of Fiji in 1970 to that in 1975?
Your answer should be very brief. 1.06. What is the ratio of the Official exchange rate (LCU per US$ period average) of St. Lucia in 1970 to that in 1975?
Offer a very short reply. 0.92. What is the ratio of the Official exchange rate (LCU per US$ period average) of Brunei Darussalam in 1970 to that in 1976?
Your response must be concise. 1.24. What is the ratio of the Official exchange rate (LCU per US$ period average) of Fiji in 1970 to that in 1976?
Give a very brief answer. 0.97. What is the ratio of the Official exchange rate (LCU per US$ period average) of St. Lucia in 1970 to that in 1976?
Provide a succinct answer. 0.76. What is the ratio of the Official exchange rate (LCU per US$ period average) in Brunei Darussalam in 1971 to that in 1972?
Give a very brief answer. 1.08. What is the ratio of the Official exchange rate (LCU per US$ period average) of Fiji in 1971 to that in 1972?
Provide a succinct answer. 1.04. What is the ratio of the Official exchange rate (LCU per US$ period average) in St. Lucia in 1971 to that in 1972?
Provide a short and direct response. 1.03. What is the ratio of the Official exchange rate (LCU per US$ period average) in Brunei Darussalam in 1971 to that in 1973?
Ensure brevity in your answer.  1.24. What is the ratio of the Official exchange rate (LCU per US$ period average) of Fiji in 1971 to that in 1973?
Provide a short and direct response. 1.08. What is the ratio of the Official exchange rate (LCU per US$ period average) in St. Lucia in 1971 to that in 1973?
Give a very brief answer. 1.01. What is the ratio of the Official exchange rate (LCU per US$ period average) in Brunei Darussalam in 1971 to that in 1974?
Make the answer very short. 1.25. What is the ratio of the Official exchange rate (LCU per US$ period average) in Fiji in 1971 to that in 1974?
Make the answer very short. 1.07. What is the ratio of the Official exchange rate (LCU per US$ period average) of St. Lucia in 1971 to that in 1974?
Keep it short and to the point. 0.96. What is the ratio of the Official exchange rate (LCU per US$ period average) in Brunei Darussalam in 1971 to that in 1975?
Ensure brevity in your answer.  1.29. What is the ratio of the Official exchange rate (LCU per US$ period average) of Fiji in 1971 to that in 1975?
Keep it short and to the point. 1.04. What is the ratio of the Official exchange rate (LCU per US$ period average) in St. Lucia in 1971 to that in 1975?
Offer a very short reply. 0.91. What is the ratio of the Official exchange rate (LCU per US$ period average) in Brunei Darussalam in 1971 to that in 1976?
Provide a short and direct response. 1.24. What is the ratio of the Official exchange rate (LCU per US$ period average) in Fiji in 1971 to that in 1976?
Make the answer very short. 0.96. What is the ratio of the Official exchange rate (LCU per US$ period average) of St. Lucia in 1971 to that in 1976?
Give a very brief answer. 0.76. What is the ratio of the Official exchange rate (LCU per US$ period average) of Brunei Darussalam in 1972 to that in 1973?
Ensure brevity in your answer.  1.15. What is the ratio of the Official exchange rate (LCU per US$ period average) in Fiji in 1972 to that in 1973?
Your answer should be compact. 1.04. What is the ratio of the Official exchange rate (LCU per US$ period average) of St. Lucia in 1972 to that in 1973?
Keep it short and to the point. 0.98. What is the ratio of the Official exchange rate (LCU per US$ period average) in Brunei Darussalam in 1972 to that in 1974?
Provide a succinct answer. 1.16. What is the ratio of the Official exchange rate (LCU per US$ period average) of Fiji in 1972 to that in 1974?
Give a very brief answer. 1.02. What is the ratio of the Official exchange rate (LCU per US$ period average) in St. Lucia in 1972 to that in 1974?
Your response must be concise. 0.94. What is the ratio of the Official exchange rate (LCU per US$ period average) of Brunei Darussalam in 1972 to that in 1975?
Your answer should be compact. 1.19. What is the ratio of the Official exchange rate (LCU per US$ period average) in St. Lucia in 1972 to that in 1975?
Offer a very short reply. 0.89. What is the ratio of the Official exchange rate (LCU per US$ period average) in Brunei Darussalam in 1972 to that in 1976?
Your answer should be compact. 1.14. What is the ratio of the Official exchange rate (LCU per US$ period average) of Fiji in 1972 to that in 1976?
Keep it short and to the point. 0.92. What is the ratio of the Official exchange rate (LCU per US$ period average) in St. Lucia in 1972 to that in 1976?
Your answer should be compact. 0.73. What is the ratio of the Official exchange rate (LCU per US$ period average) in Brunei Darussalam in 1973 to that in 1974?
Ensure brevity in your answer.  1.01. What is the ratio of the Official exchange rate (LCU per US$ period average) in Fiji in 1973 to that in 1974?
Your answer should be compact. 0.99. What is the ratio of the Official exchange rate (LCU per US$ period average) in St. Lucia in 1973 to that in 1974?
Keep it short and to the point. 0.95. What is the ratio of the Official exchange rate (LCU per US$ period average) in Brunei Darussalam in 1973 to that in 1975?
Provide a succinct answer. 1.04. What is the ratio of the Official exchange rate (LCU per US$ period average) in Fiji in 1973 to that in 1975?
Offer a terse response. 0.97. What is the ratio of the Official exchange rate (LCU per US$ period average) of St. Lucia in 1973 to that in 1975?
Offer a very short reply. 0.9. What is the ratio of the Official exchange rate (LCU per US$ period average) of Fiji in 1973 to that in 1976?
Provide a succinct answer. 0.88. What is the ratio of the Official exchange rate (LCU per US$ period average) in St. Lucia in 1973 to that in 1976?
Your response must be concise. 0.75. What is the ratio of the Official exchange rate (LCU per US$ period average) of Brunei Darussalam in 1974 to that in 1975?
Offer a very short reply. 1.03. What is the ratio of the Official exchange rate (LCU per US$ period average) in Fiji in 1974 to that in 1975?
Offer a very short reply. 0.98. What is the ratio of the Official exchange rate (LCU per US$ period average) of St. Lucia in 1974 to that in 1975?
Provide a succinct answer. 0.95. What is the ratio of the Official exchange rate (LCU per US$ period average) in Brunei Darussalam in 1974 to that in 1976?
Provide a short and direct response. 0.99. What is the ratio of the Official exchange rate (LCU per US$ period average) in Fiji in 1974 to that in 1976?
Your answer should be compact. 0.9. What is the ratio of the Official exchange rate (LCU per US$ period average) of St. Lucia in 1974 to that in 1976?
Provide a short and direct response. 0.79. What is the ratio of the Official exchange rate (LCU per US$ period average) of Brunei Darussalam in 1975 to that in 1976?
Your answer should be compact. 0.96. What is the ratio of the Official exchange rate (LCU per US$ period average) in Fiji in 1975 to that in 1976?
Give a very brief answer. 0.92. What is the ratio of the Official exchange rate (LCU per US$ period average) of St. Lucia in 1975 to that in 1976?
Keep it short and to the point. 0.83. What is the difference between the highest and the second highest Official exchange rate (LCU per US$ period average) in Fiji?
Your answer should be compact. 0.03. What is the difference between the highest and the second highest Official exchange rate (LCU per US$ period average) in St. Lucia?
Ensure brevity in your answer.  0.44. What is the difference between the highest and the lowest Official exchange rate (LCU per US$ period average) in Brunei Darussalam?
Make the answer very short. 0.69. What is the difference between the highest and the lowest Official exchange rate (LCU per US$ period average) in Fiji?
Provide a short and direct response. 0.1. What is the difference between the highest and the lowest Official exchange rate (LCU per US$ period average) of St. Lucia?
Make the answer very short. 0.69. 